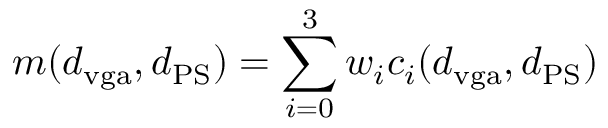Convert formula to latex. <formula><loc_0><loc_0><loc_500><loc_500>m ( d _ { v g a } , d _ { P S } ) = \sum _ { i = 0 } ^ { 3 } w _ { i } c _ { i } ( d _ { v g a } , d _ { P S } )</formula> 